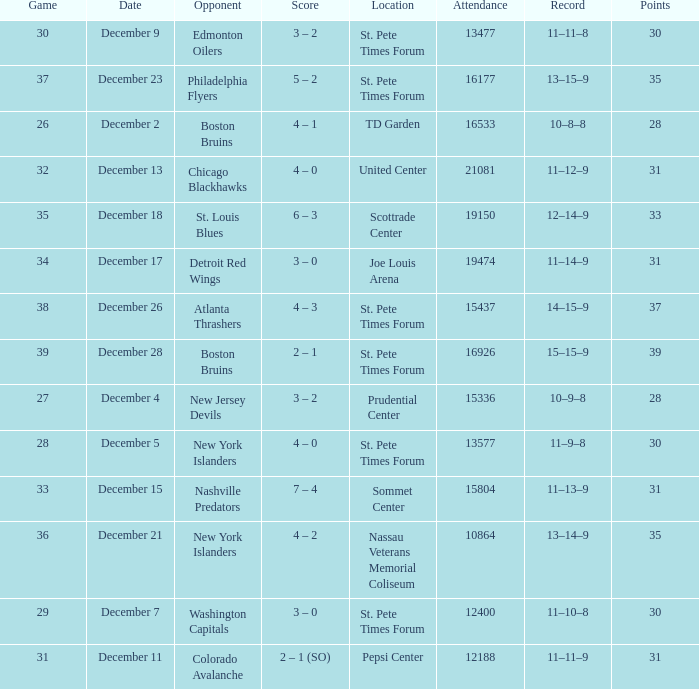Give me the full table as a dictionary. {'header': ['Game', 'Date', 'Opponent', 'Score', 'Location', 'Attendance', 'Record', 'Points'], 'rows': [['30', 'December 9', 'Edmonton Oilers', '3 – 2', 'St. Pete Times Forum', '13477', '11–11–8', '30'], ['37', 'December 23', 'Philadelphia Flyers', '5 – 2', 'St. Pete Times Forum', '16177', '13–15–9', '35'], ['26', 'December 2', 'Boston Bruins', '4 – 1', 'TD Garden', '16533', '10–8–8', '28'], ['32', 'December 13', 'Chicago Blackhawks', '4 – 0', 'United Center', '21081', '11–12–9', '31'], ['35', 'December 18', 'St. Louis Blues', '6 – 3', 'Scottrade Center', '19150', '12–14–9', '33'], ['34', 'December 17', 'Detroit Red Wings', '3 – 0', 'Joe Louis Arena', '19474', '11–14–9', '31'], ['38', 'December 26', 'Atlanta Thrashers', '4 – 3', 'St. Pete Times Forum', '15437', '14–15–9', '37'], ['39', 'December 28', 'Boston Bruins', '2 – 1', 'St. Pete Times Forum', '16926', '15–15–9', '39'], ['27', 'December 4', 'New Jersey Devils', '3 – 2', 'Prudential Center', '15336', '10–9–8', '28'], ['28', 'December 5', 'New York Islanders', '4 – 0', 'St. Pete Times Forum', '13577', '11–9–8', '30'], ['33', 'December 15', 'Nashville Predators', '7 – 4', 'Sommet Center', '15804', '11–13–9', '31'], ['36', 'December 21', 'New York Islanders', '4 – 2', 'Nassau Veterans Memorial Coliseum', '10864', '13–14–9', '35'], ['29', 'December 7', 'Washington Capitals', '3 – 0', 'St. Pete Times Forum', '12400', '11–10–8', '30'], ['31', 'December 11', 'Colorado Avalanche', '2 – 1 (SO)', 'Pepsi Center', '12188', '11–11–9', '31']]} What was the largest attended game? 21081.0. 